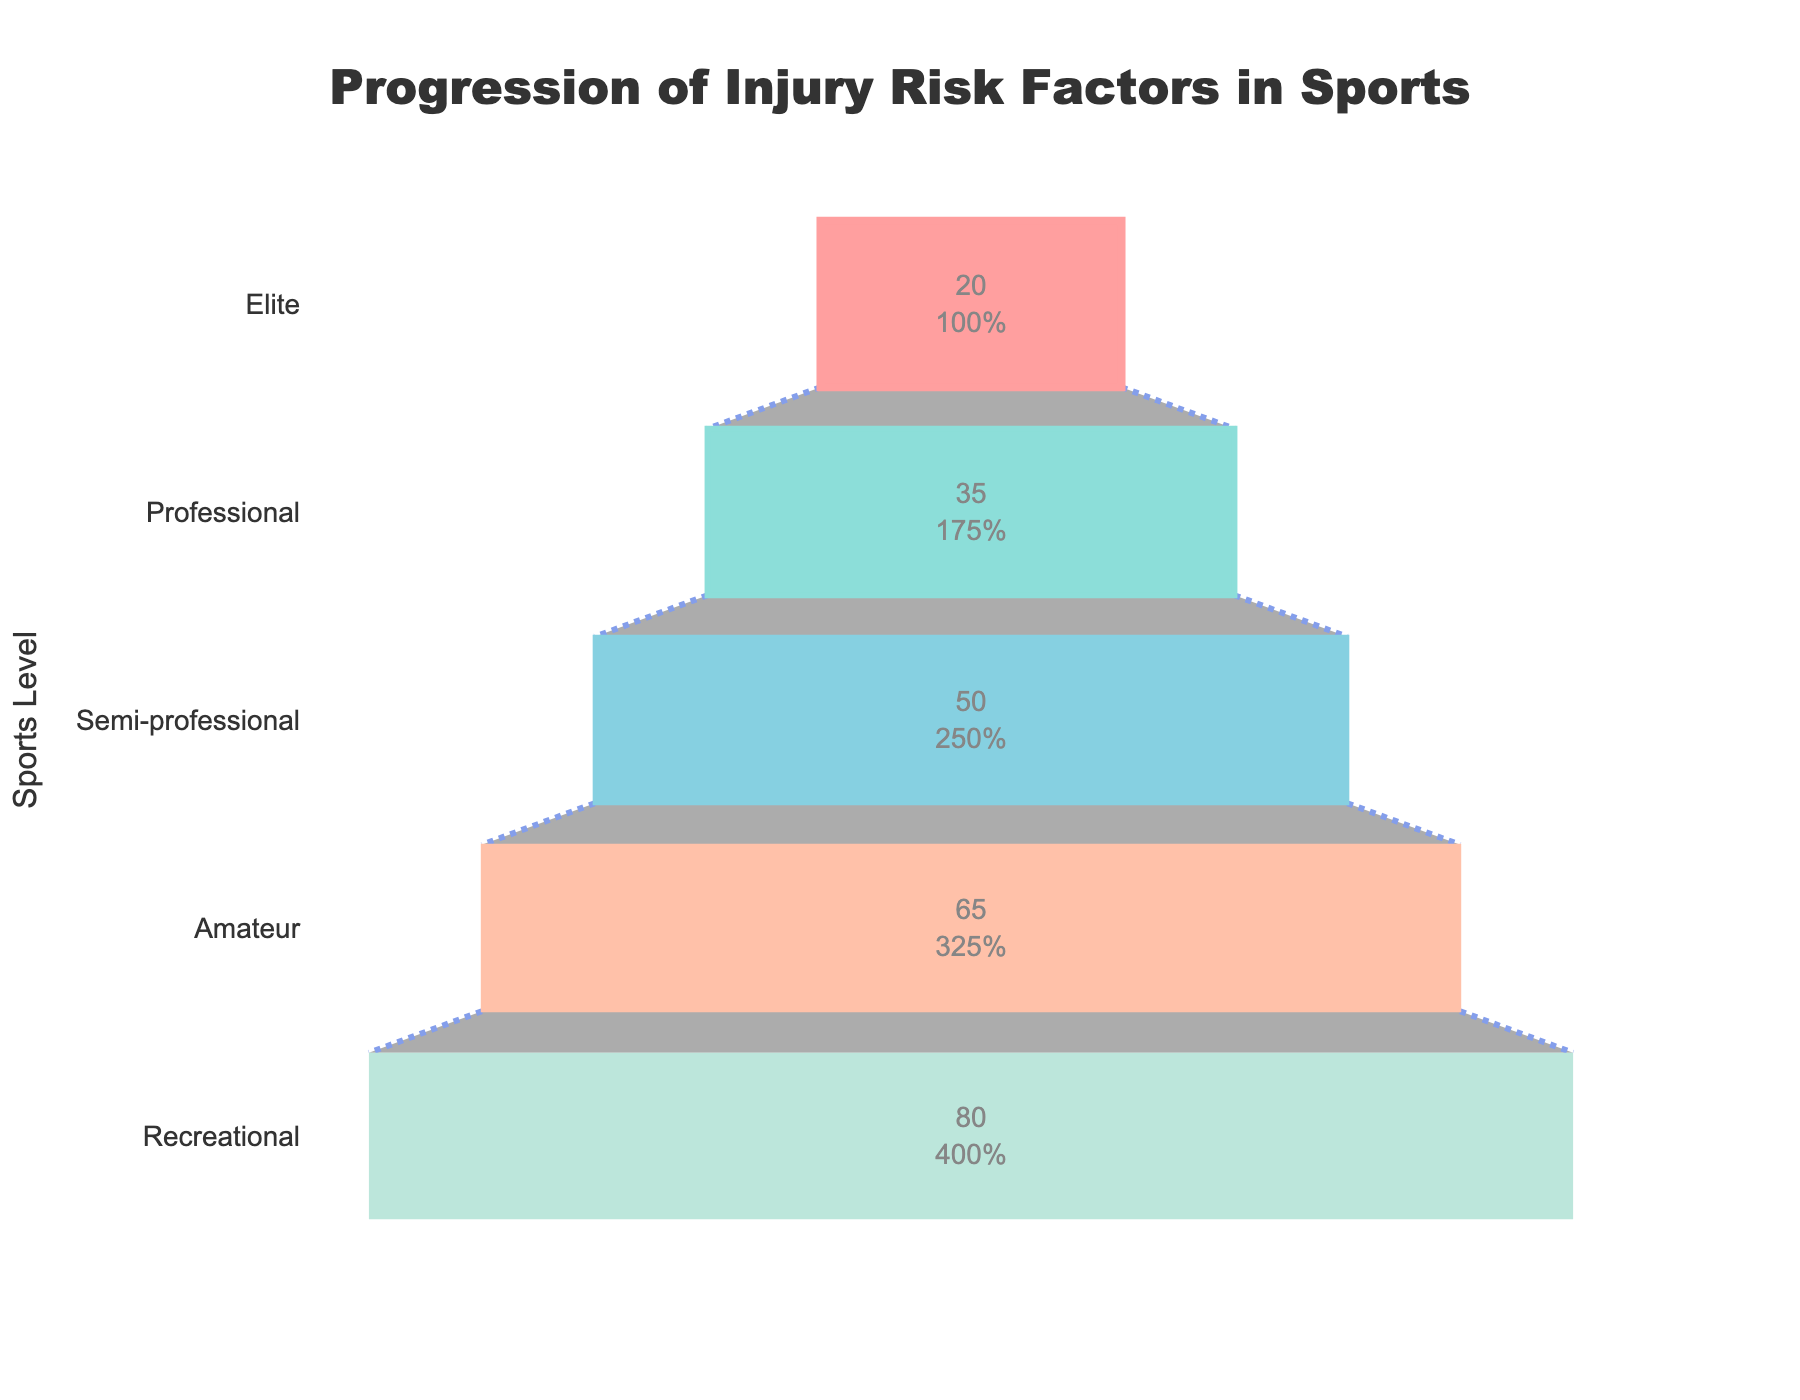What is the percentage of athletes affected by psychological stress at the elite level? The funnel chart shows percentages for each level. For the elite level, the bar width indicates 20%.
Answer: 20% What is the title of the funnel chart? The title is displayed at the top of the chart, in the center, and reads "Progression of Injury Risk Factors in Sports".
Answer: Progression of Injury Risk Factors in Sports Which level has the highest percentage of overuse injuries? The chart begins with the widest section at the bottom and ends with the narrowest. The recreational level is at the bottom with 80%.
Answer: Recreational By how much percent does the percentage of inadequate warm-up decrease from amateur to semi-professional levels? The amateur level shows 65% inadequate warm-up, and the semi-professional level shows 50%. Subtract 50 from 65.
Answer: 15% Which level shows a 50% rate of muscular imbalances? The semi-professional level corresponds to a rate of 50% muscular imbalances in the chart.
Answer: Semi-professional Compare the percentage reduction in injury risk factors from professional to elite levels. Professional level has 35% insufficient recovery time, and elite has 20% psychological stress. The reduction is 35% - 20%.
Answer: 15% Which injury risk factor is common among professional athletes, and what percentage does it affect? The professional level shows insufficient recovery time, affecting 35% of athletes.
Answer: Insufficient recovery time, 35% What can be inferred about the trend of injury risk factors from recreational to elite levels? The chart shows a decreasing trend where the percentage of injury risk factors reduces as the sports level progresses from recreational (80%) to elite (20%).
Answer: Decreasing trend Among the factors listed, which injury risk factor has the least impact, and at what level? The narrowest section at the top of the funnel indicates the elite level with 20% psychological stress, the least impact.
Answer: Psychological stress, elite How much higher is the percentage of athletes with overuse injuries at the recreational level compared to psychological stress at the elite level? Overuse injuries at the recreational level are 80%, and psychological stress at the elite level is 20%. The difference is 80% - 20%.
Answer: 60% 